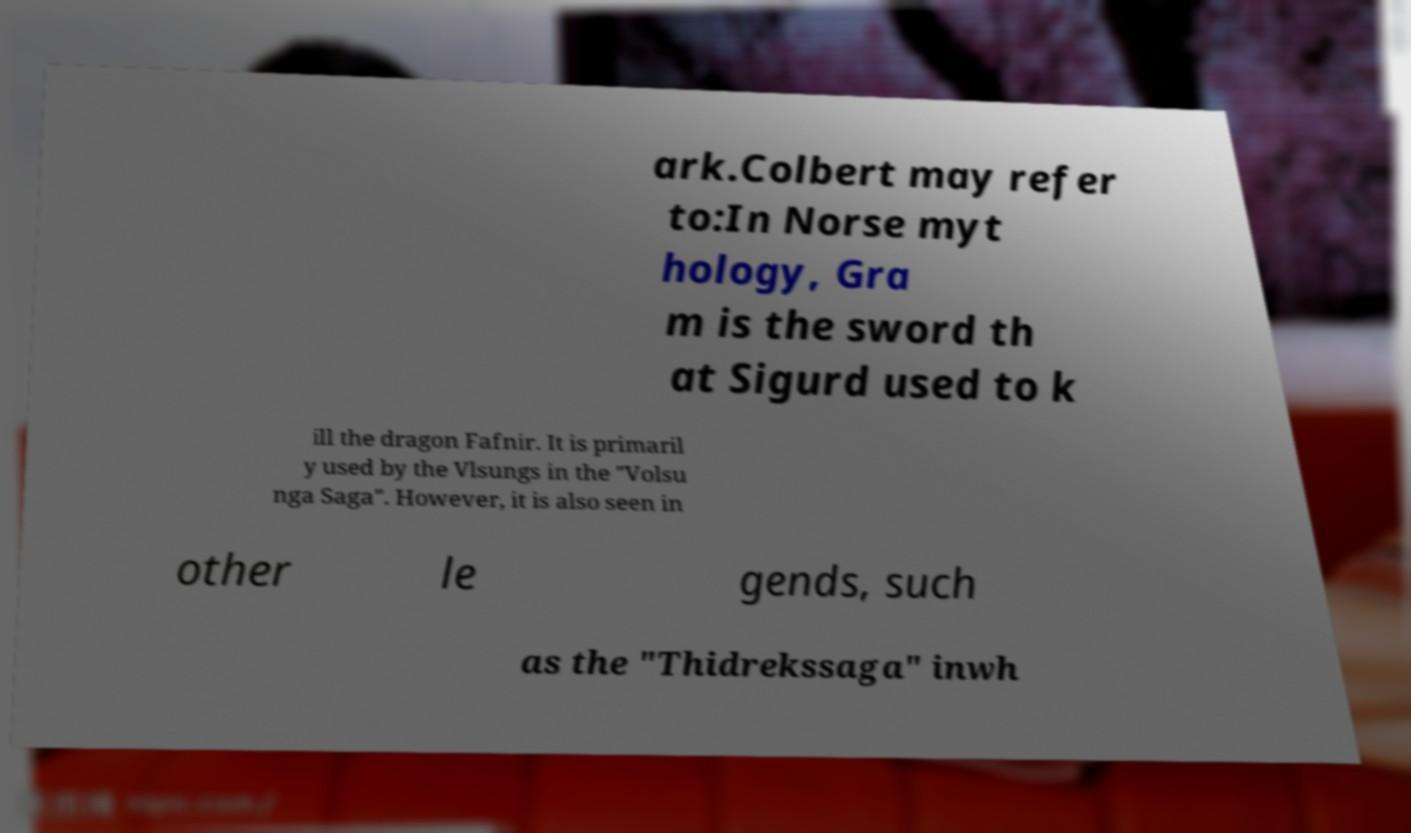For documentation purposes, I need the text within this image transcribed. Could you provide that? ark.Colbert may refer to:In Norse myt hology, Gra m is the sword th at Sigurd used to k ill the dragon Fafnir. It is primaril y used by the Vlsungs in the "Volsu nga Saga". However, it is also seen in other le gends, such as the "Thidrekssaga" inwh 